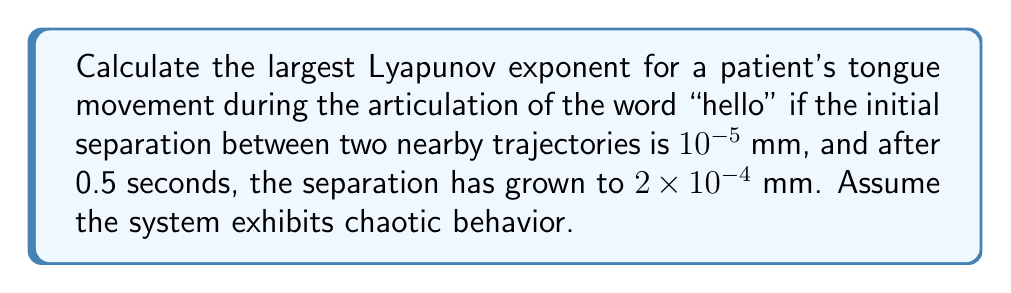What is the answer to this math problem? To calculate the largest Lyapunov exponent (λ) for the tongue movement, we'll use the formula:

$$\lambda = \frac{1}{t} \ln\left(\frac{d(t)}{d(0)}\right)$$

Where:
- $t$ is the time interval
- $d(0)$ is the initial separation
- $d(t)$ is the separation after time $t$

Step 1: Identify the given values
- $t = 0.5$ seconds
- $d(0) = 10^{-5}$ mm
- $d(t) = 2 \times 10^{-4}$ mm

Step 2: Substitute the values into the formula

$$\lambda = \frac{1}{0.5} \ln\left(\frac{2 \times 10^{-4}}{10^{-5}}\right)$$

Step 3: Simplify the fraction inside the logarithm

$$\lambda = \frac{1}{0.5} \ln(20)$$

Step 4: Calculate the natural logarithm

$$\lambda = \frac{1}{0.5} \times 2.9957$$

Step 5: Perform the final division

$$\lambda = 5.9914$$

The largest Lyapunov exponent is approximately 5.9914 s⁻¹, indicating chaotic behavior in the tongue movement during articulation.
Answer: $5.9914$ s⁻¹ 